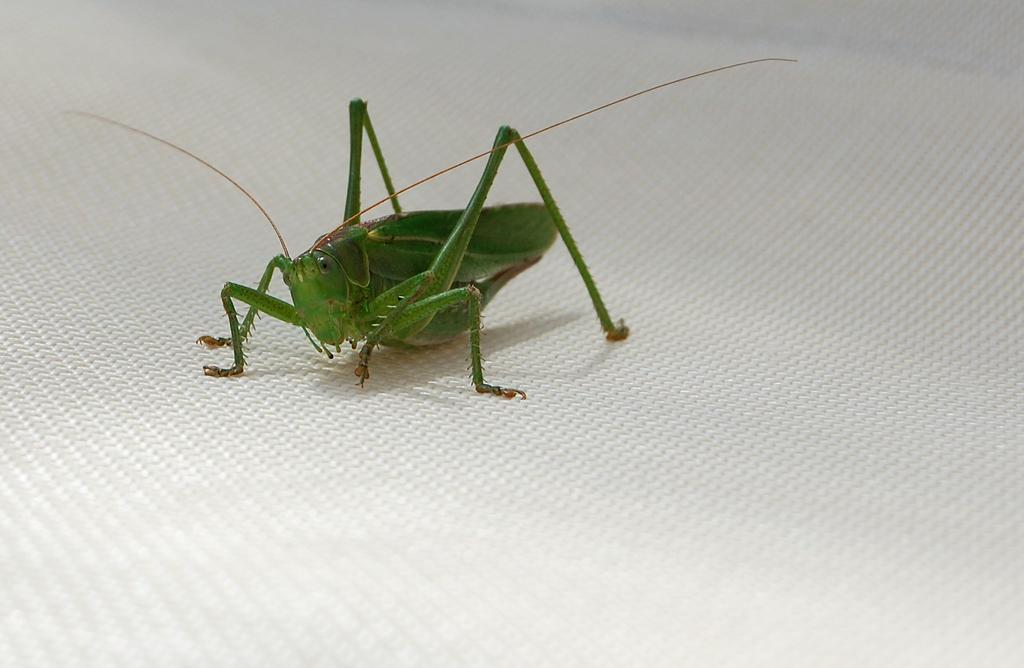What type of picture is shown in the image? The image is a zoomed-in picture. What can be seen in the zoomed-in picture? There is a locust in the image. What is the background or surface on which the locust is located? The locust is on a white surface. What type of activity is the locust participating in on the coast in the image? There is no coast or activity involving the locust in the image; it is simply a locust on a white surface. 